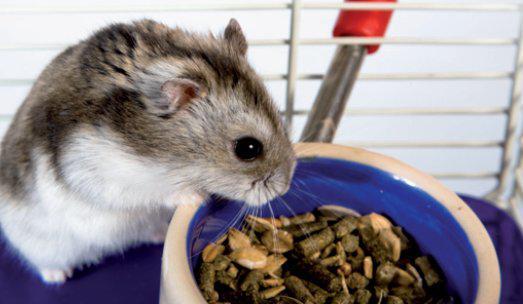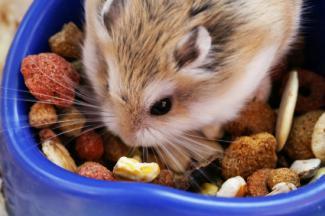The first image is the image on the left, the second image is the image on the right. Evaluate the accuracy of this statement regarding the images: "In the image on the left an animal is sitting in a bowl.". Is it true? Answer yes or no. No. The first image is the image on the left, the second image is the image on the right. Examine the images to the left and right. Is the description "The hamster in the left image is inside a bowl, and the hamster on the right is next to a bowl filled with pet food." accurate? Answer yes or no. No. 